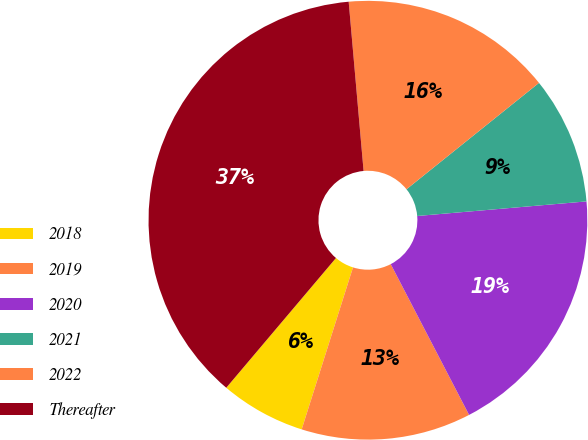Convert chart to OTSL. <chart><loc_0><loc_0><loc_500><loc_500><pie_chart><fcel>2018<fcel>2019<fcel>2020<fcel>2021<fcel>2022<fcel>Thereafter<nl><fcel>6.29%<fcel>12.51%<fcel>18.74%<fcel>9.4%<fcel>15.63%<fcel>37.43%<nl></chart> 